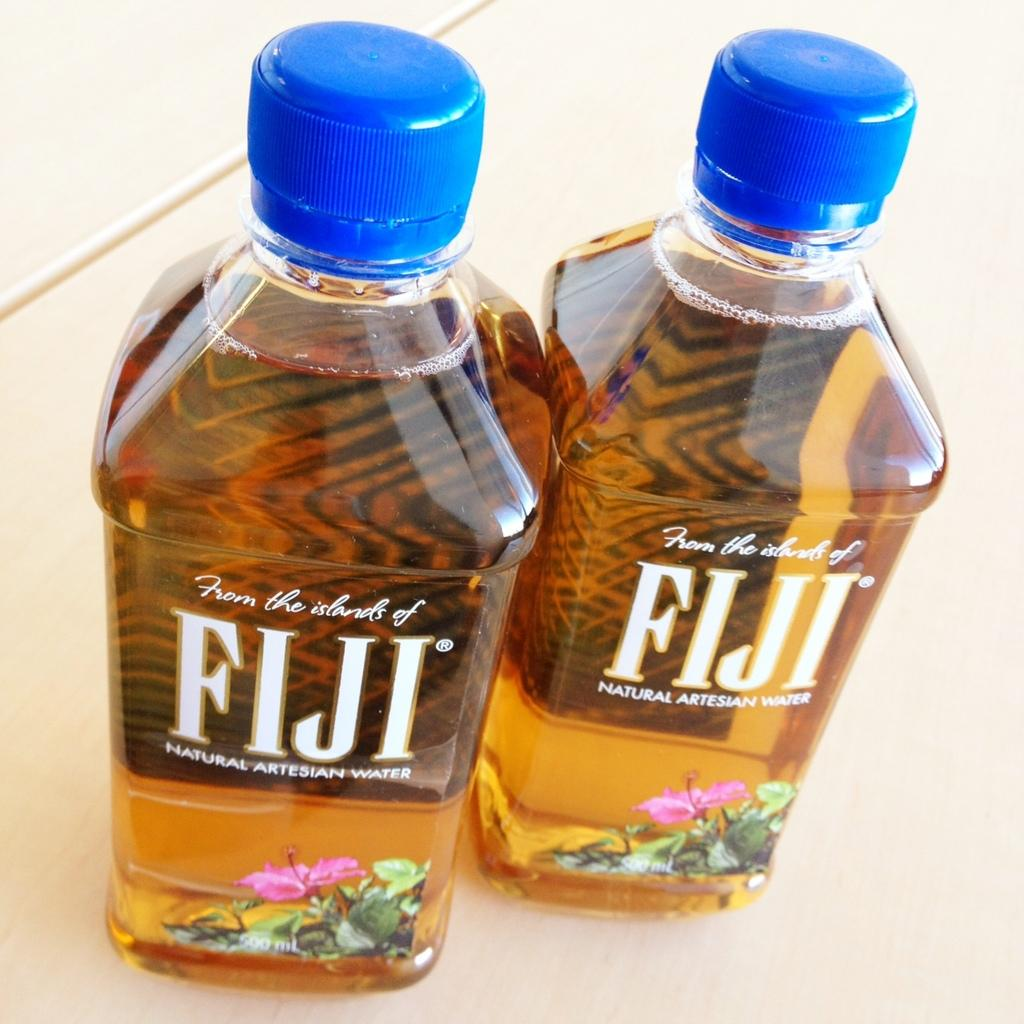<image>
Provide a brief description of the given image. Two bottles of Fiji with brown liquid inside. 